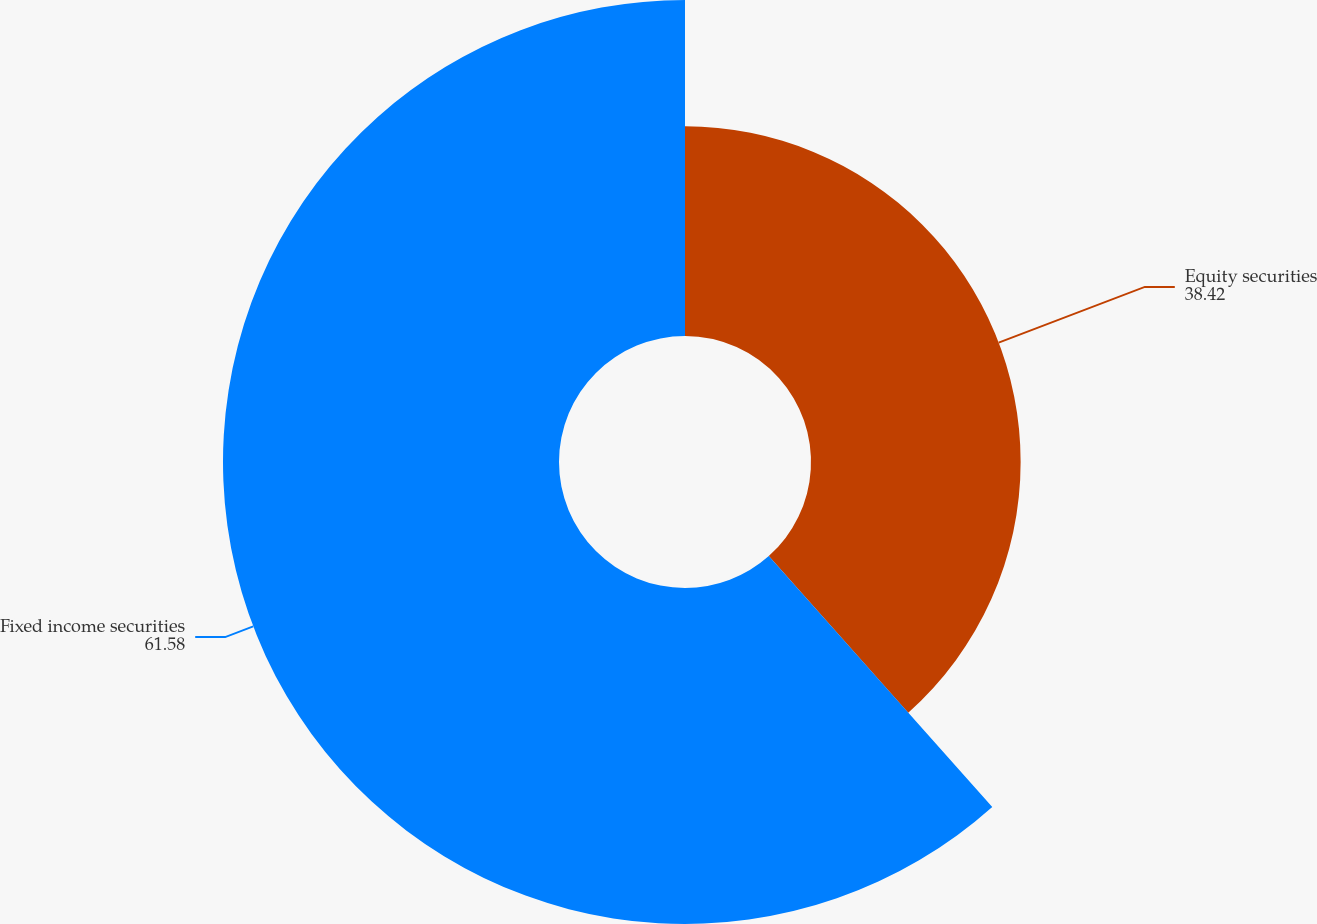Convert chart. <chart><loc_0><loc_0><loc_500><loc_500><pie_chart><fcel>Equity securities<fcel>Fixed income securities<nl><fcel>38.42%<fcel>61.58%<nl></chart> 